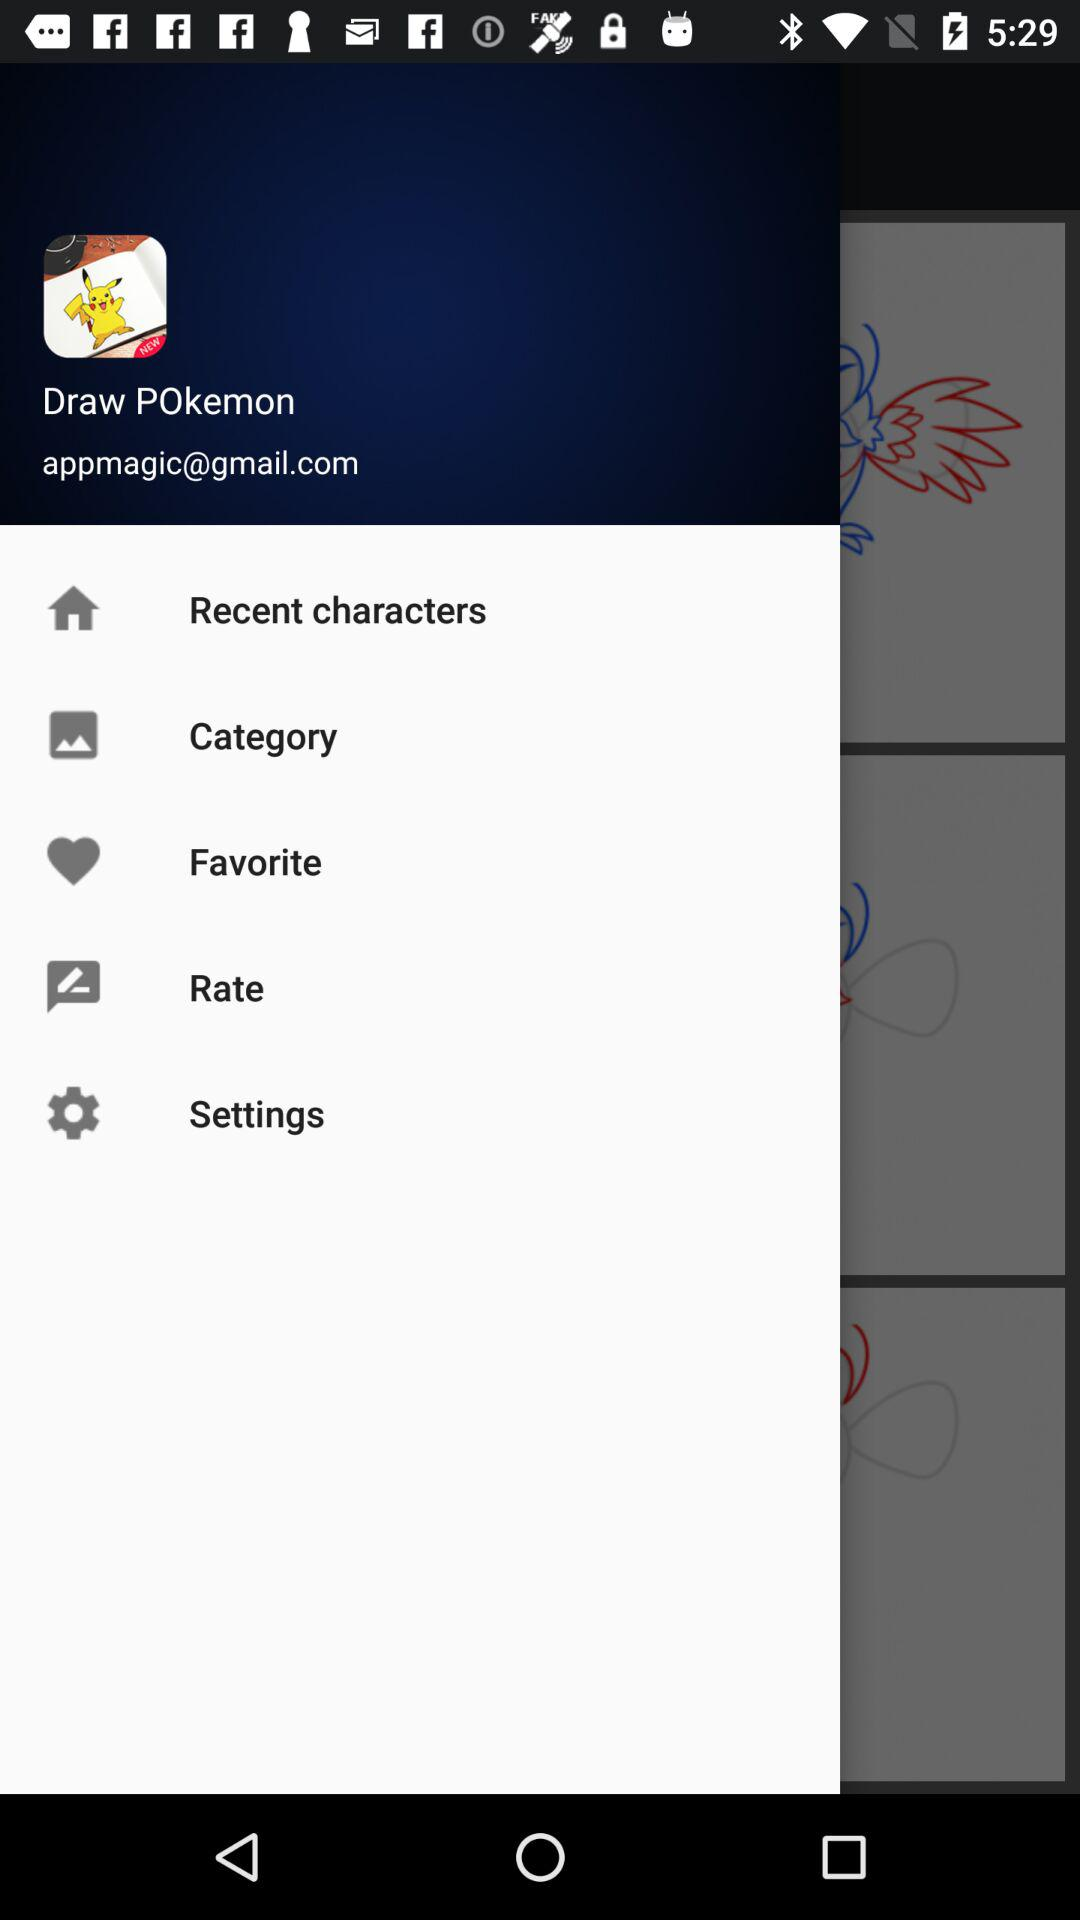What is the name of user?
When the provided information is insufficient, respond with <no answer>. <no answer> 